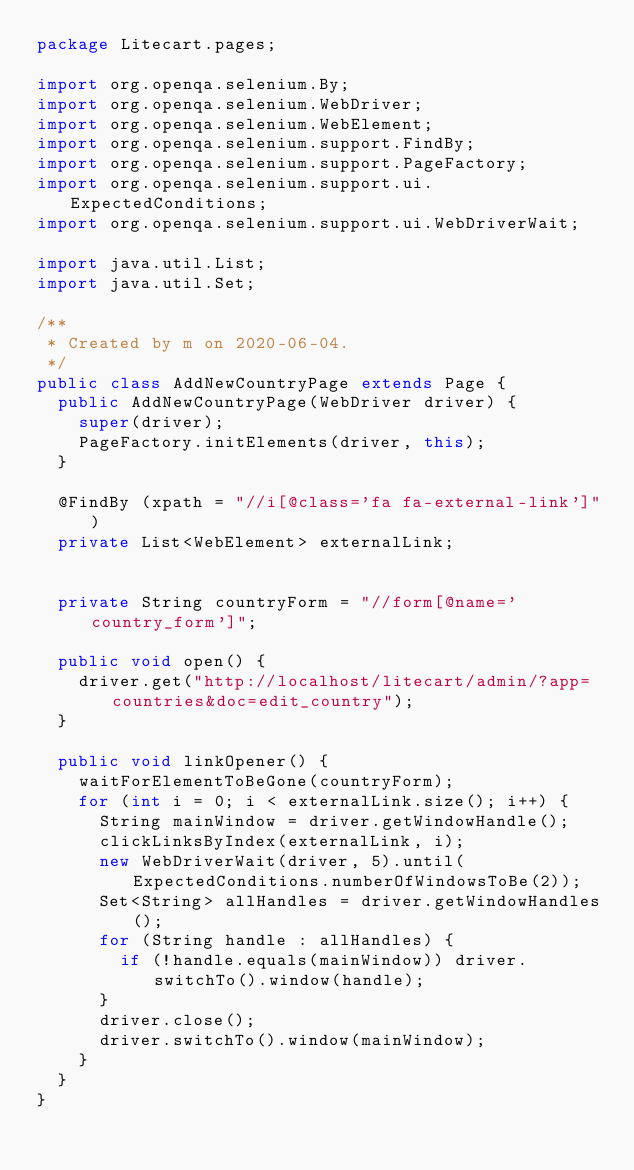<code> <loc_0><loc_0><loc_500><loc_500><_Java_>package Litecart.pages;

import org.openqa.selenium.By;
import org.openqa.selenium.WebDriver;
import org.openqa.selenium.WebElement;
import org.openqa.selenium.support.FindBy;
import org.openqa.selenium.support.PageFactory;
import org.openqa.selenium.support.ui.ExpectedConditions;
import org.openqa.selenium.support.ui.WebDriverWait;

import java.util.List;
import java.util.Set;

/**
 * Created by m on 2020-06-04.
 */
public class AddNewCountryPage extends Page {
  public AddNewCountryPage(WebDriver driver) {
    super(driver);
    PageFactory.initElements(driver, this);
  }

  @FindBy (xpath = "//i[@class='fa fa-external-link']")
  private List<WebElement> externalLink;


  private String countryForm = "//form[@name='country_form']";

  public void open() {
    driver.get("http://localhost/litecart/admin/?app=countries&doc=edit_country");
  }

  public void linkOpener() {
    waitForElementToBeGone(countryForm);
    for (int i = 0; i < externalLink.size(); i++) {
      String mainWindow = driver.getWindowHandle();
      clickLinksByIndex(externalLink, i);
      new WebDriverWait(driver, 5).until(ExpectedConditions.numberOfWindowsToBe(2));
      Set<String> allHandles = driver.getWindowHandles();
      for (String handle : allHandles) {
        if (!handle.equals(mainWindow)) driver.switchTo().window(handle);
      }
      driver.close();
      driver.switchTo().window(mainWindow);
    }
  }
}
</code> 